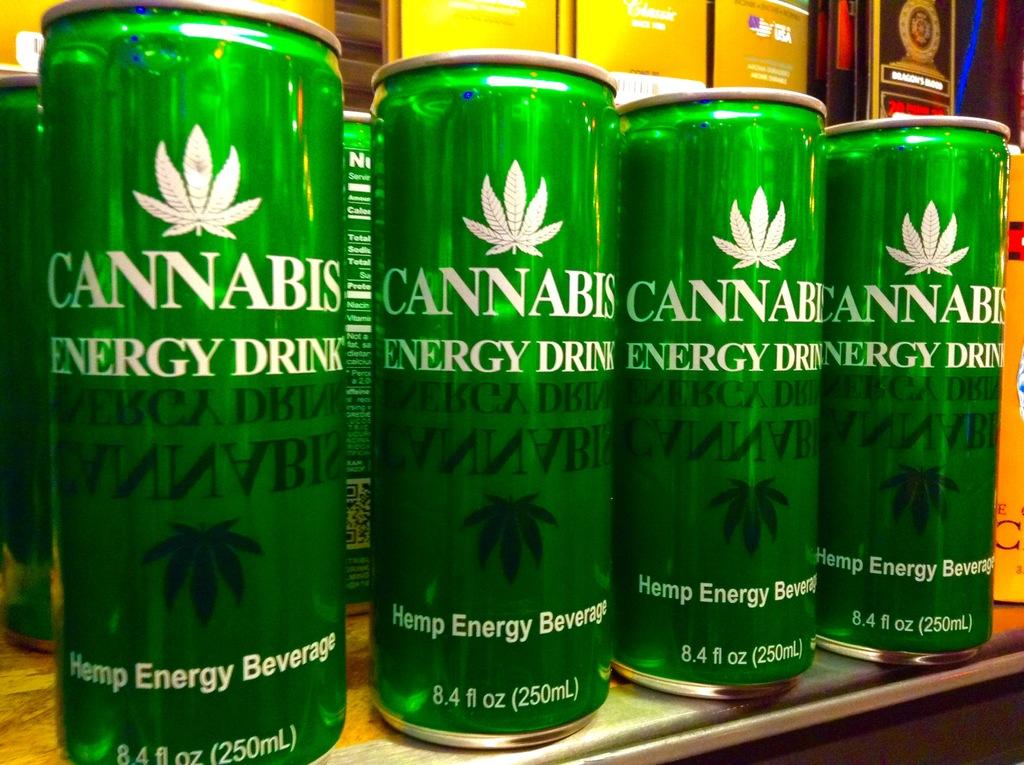What kind of energy drink is this?
Provide a short and direct response. Cannabis. 